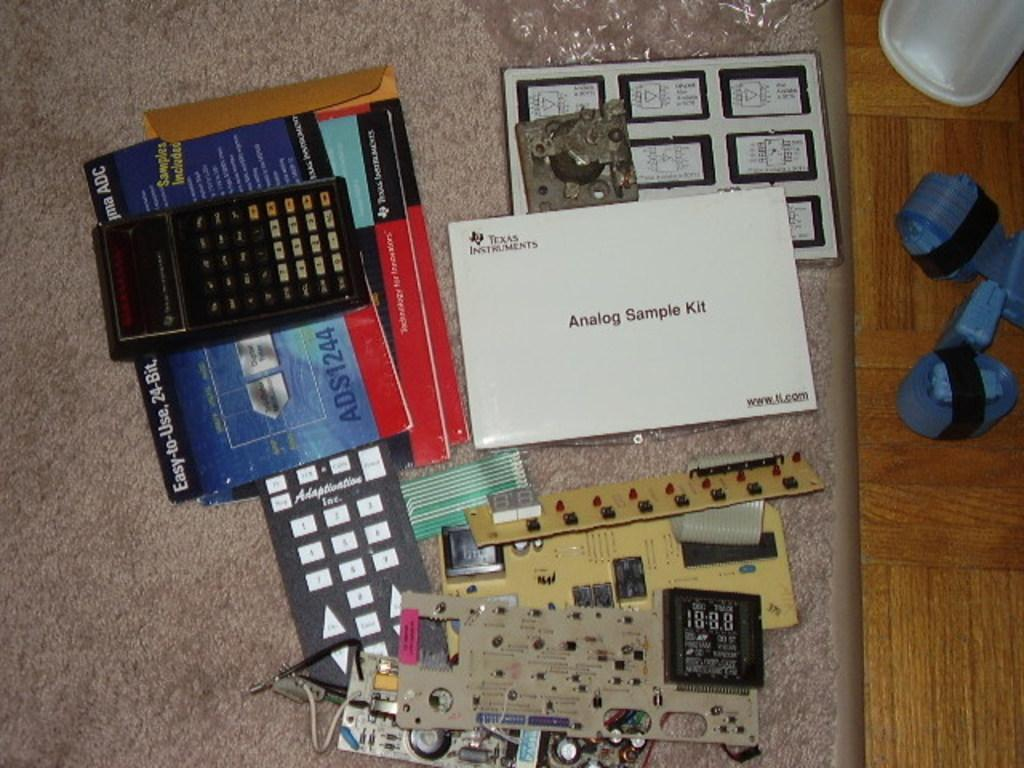<image>
Write a terse but informative summary of the picture. Various electronic components including an Analog Sample Kit 